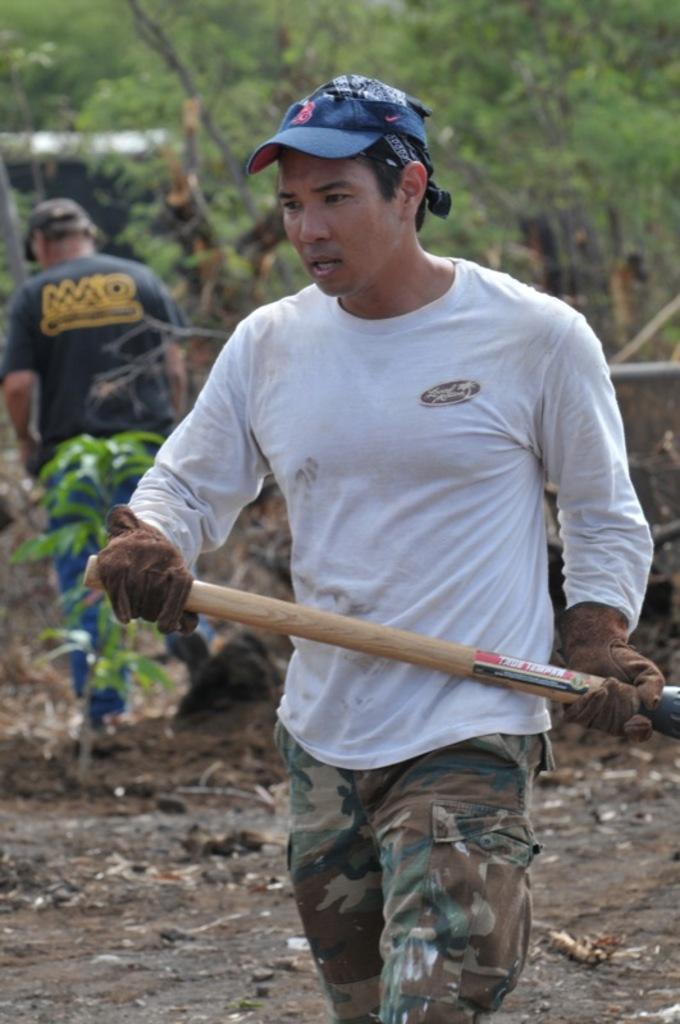How would you summarize this image in a sentence or two? In the image there is a man standing with a cap on his head and gloves to his hand is holding a wooden stick in his hand. Behind him there is a man standing and also there are trees in the background. 